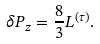Convert formula to latex. <formula><loc_0><loc_0><loc_500><loc_500>\delta P _ { z } = \frac { 8 } { 3 } L ^ { ( \tau ) } .</formula> 